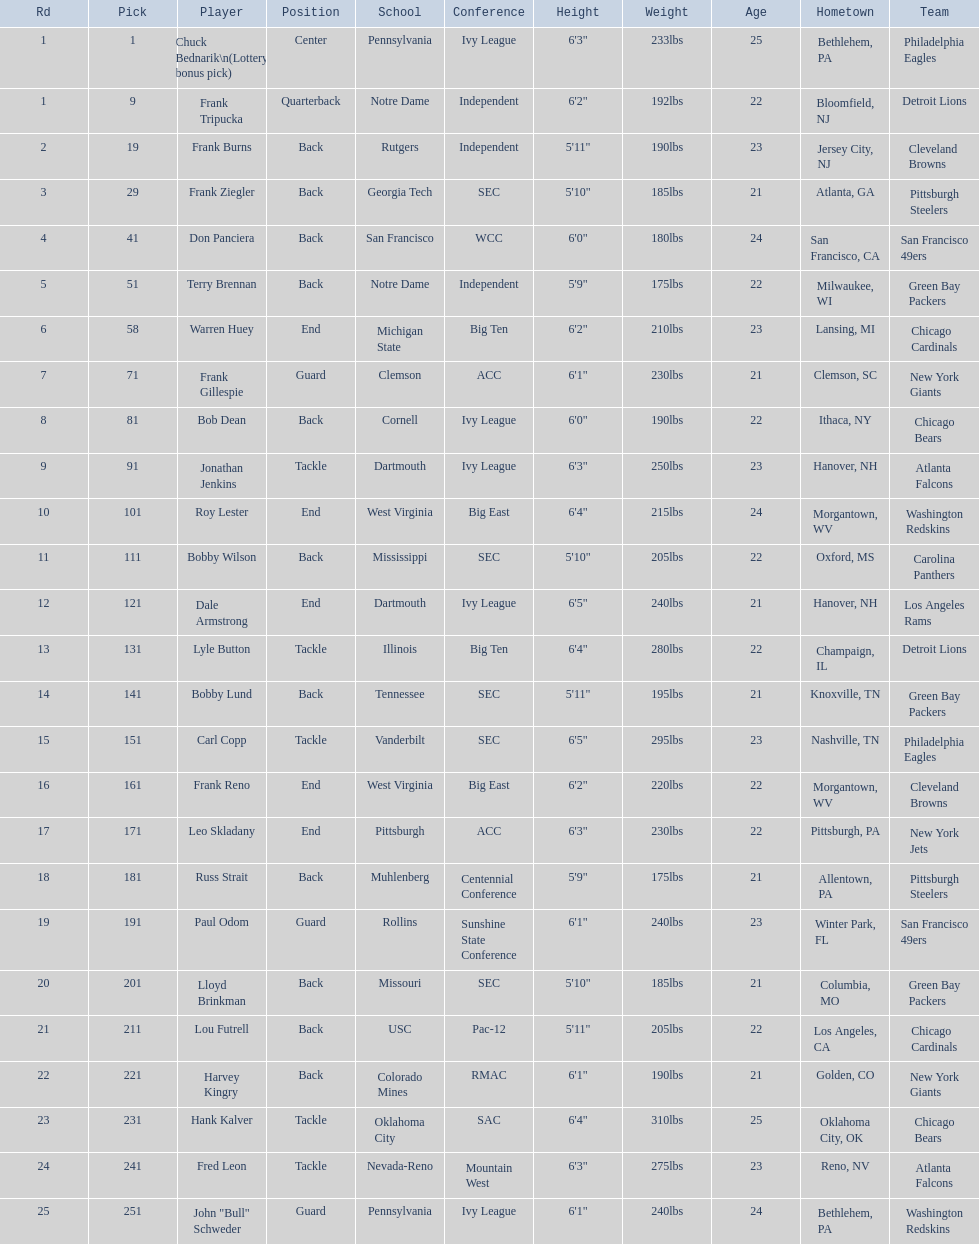Was chuck bednarik or frank tripucka the first draft pick? Chuck Bednarik. 